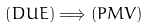<formula> <loc_0><loc_0><loc_500><loc_500>\left ( D U E \right ) \Longrightarrow \left ( P M V \right )</formula> 